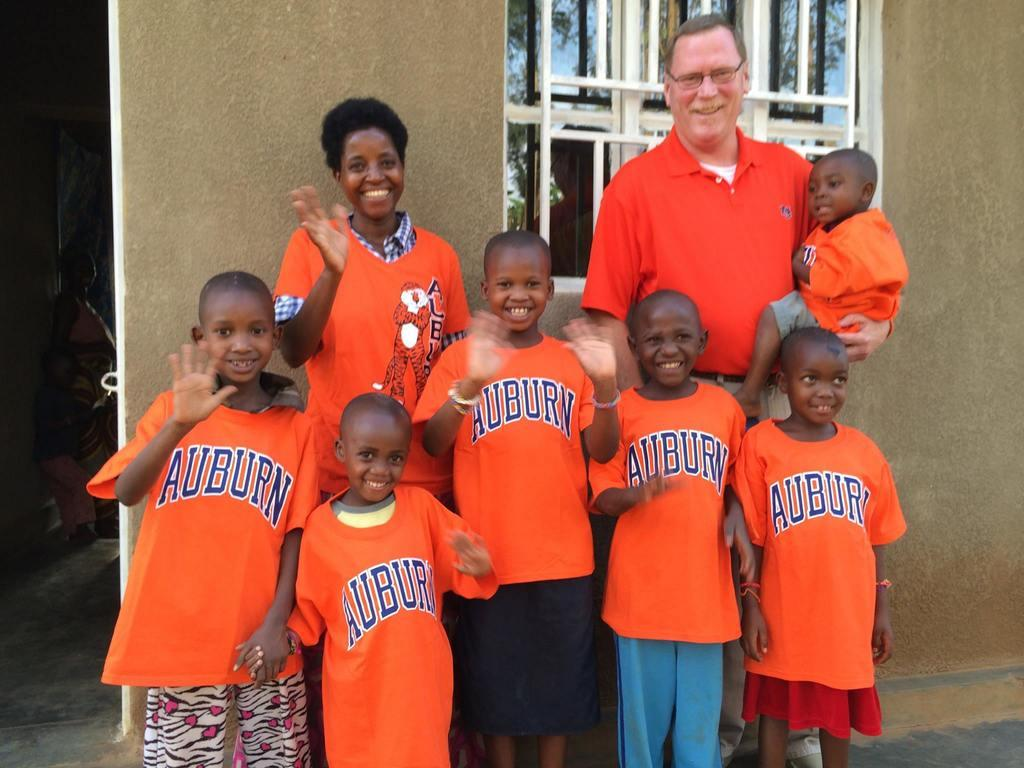<image>
Give a short and clear explanation of the subsequent image. some boys that are wearing the word auburn on their shirts 